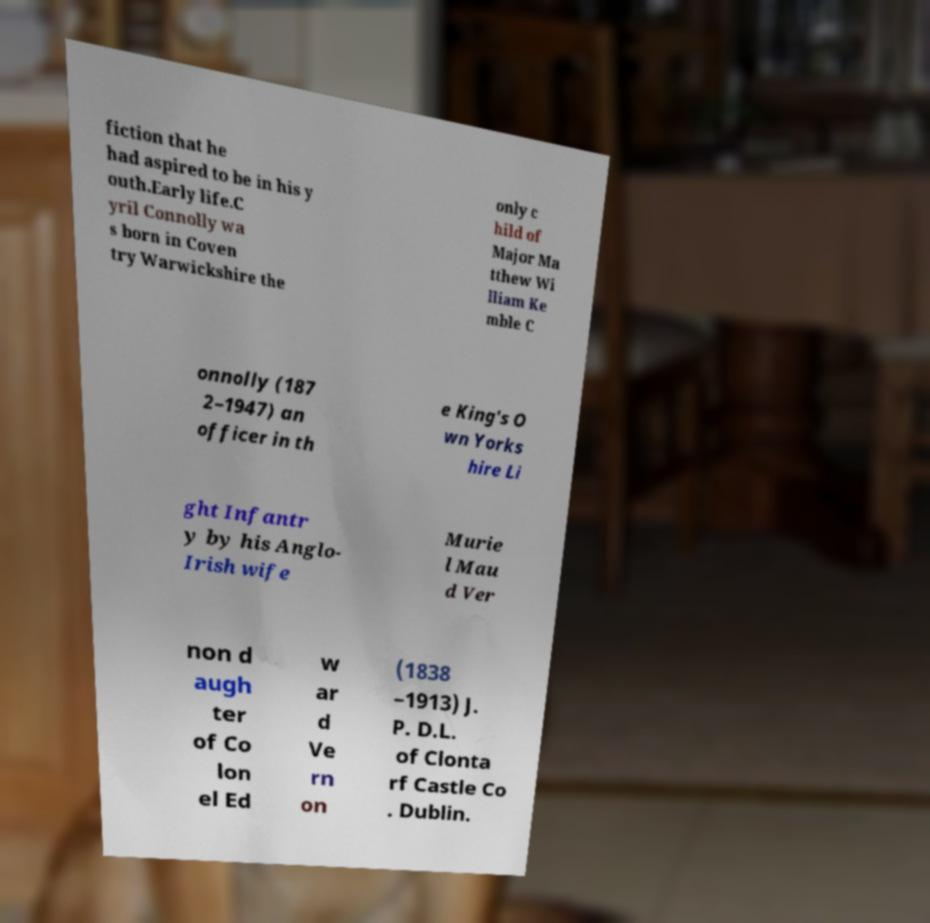Can you read and provide the text displayed in the image?This photo seems to have some interesting text. Can you extract and type it out for me? fiction that he had aspired to be in his y outh.Early life.C yril Connolly wa s born in Coven try Warwickshire the only c hild of Major Ma tthew Wi lliam Ke mble C onnolly (187 2–1947) an officer in th e King's O wn Yorks hire Li ght Infantr y by his Anglo- Irish wife Murie l Mau d Ver non d augh ter of Co lon el Ed w ar d Ve rn on (1838 –1913) J. P. D.L. of Clonta rf Castle Co . Dublin. 